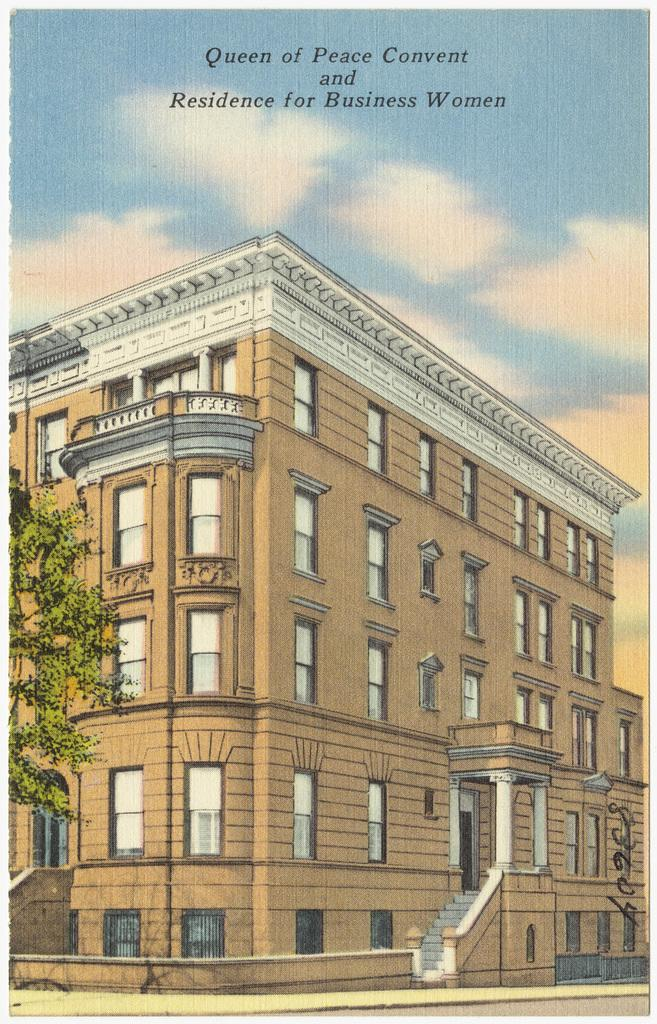What is featured on the poster in the image? The poster contains a picture of a building. What can be seen on the left side of the image? There are trees on the left side of the image. What is visible at the top of the poster? The sky and clouds are visible at the top of the poster. Where is the faucet located in the image? There is no faucet present in the image. Who is the creator of the building depicted on the poster? The image does not provide information about the creator of the building depicted on the poster. 